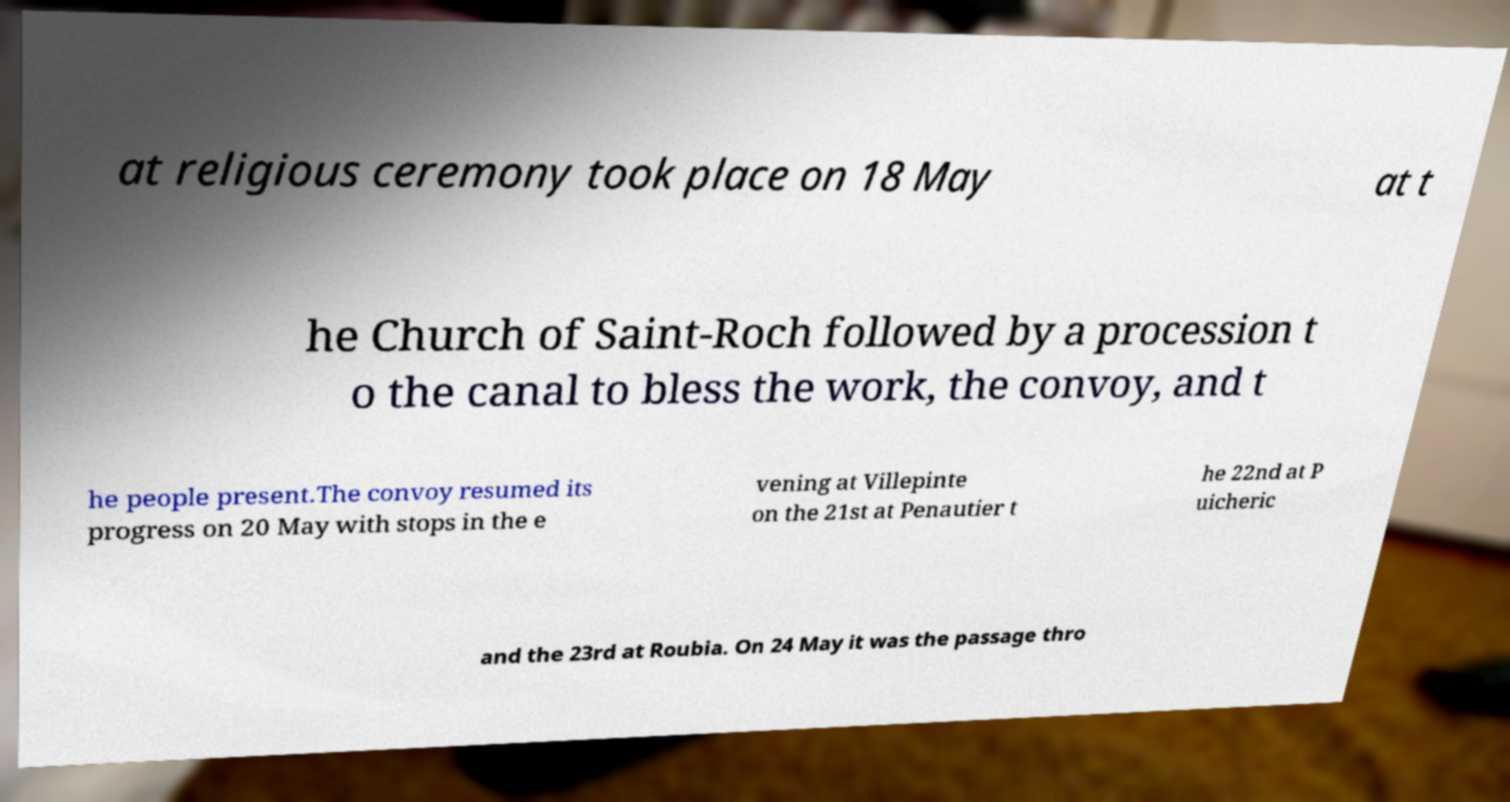Please read and relay the text visible in this image. What does it say? at religious ceremony took place on 18 May at t he Church of Saint-Roch followed by a procession t o the canal to bless the work, the convoy, and t he people present.The convoy resumed its progress on 20 May with stops in the e vening at Villepinte on the 21st at Penautier t he 22nd at P uicheric and the 23rd at Roubia. On 24 May it was the passage thro 